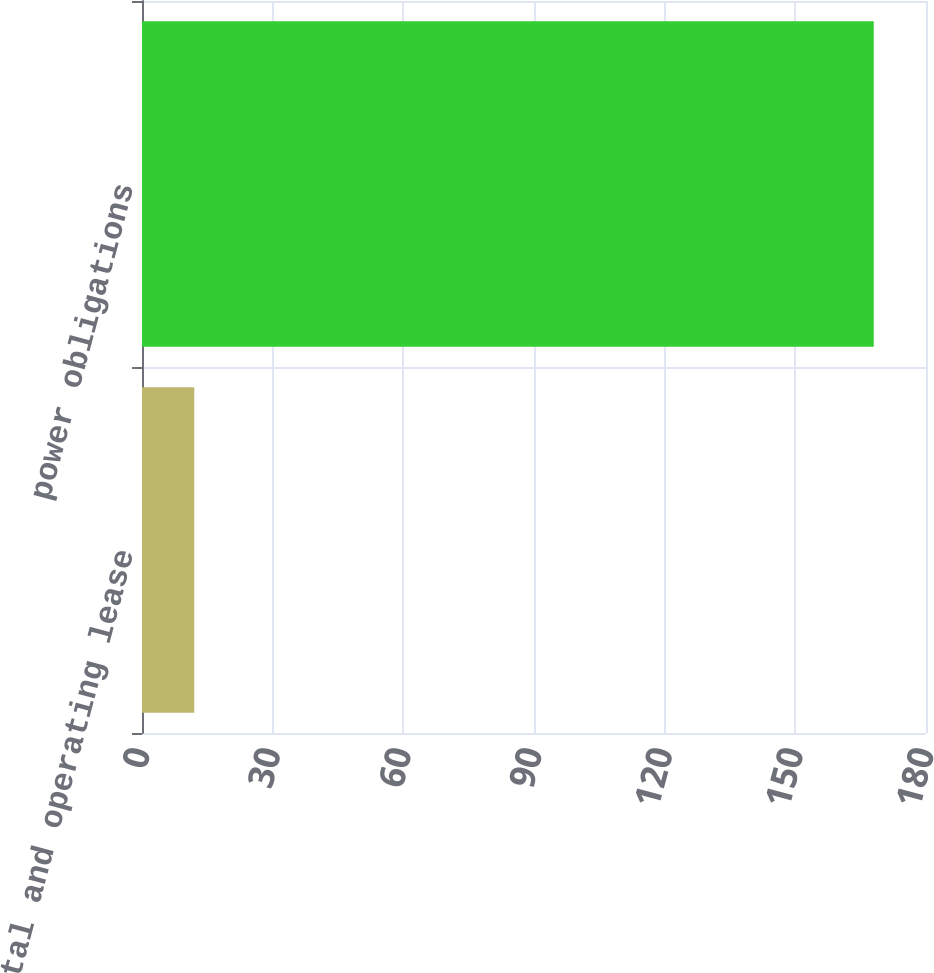Convert chart to OTSL. <chart><loc_0><loc_0><loc_500><loc_500><bar_chart><fcel>Capital and operating lease<fcel>power obligations<nl><fcel>12<fcel>168<nl></chart> 